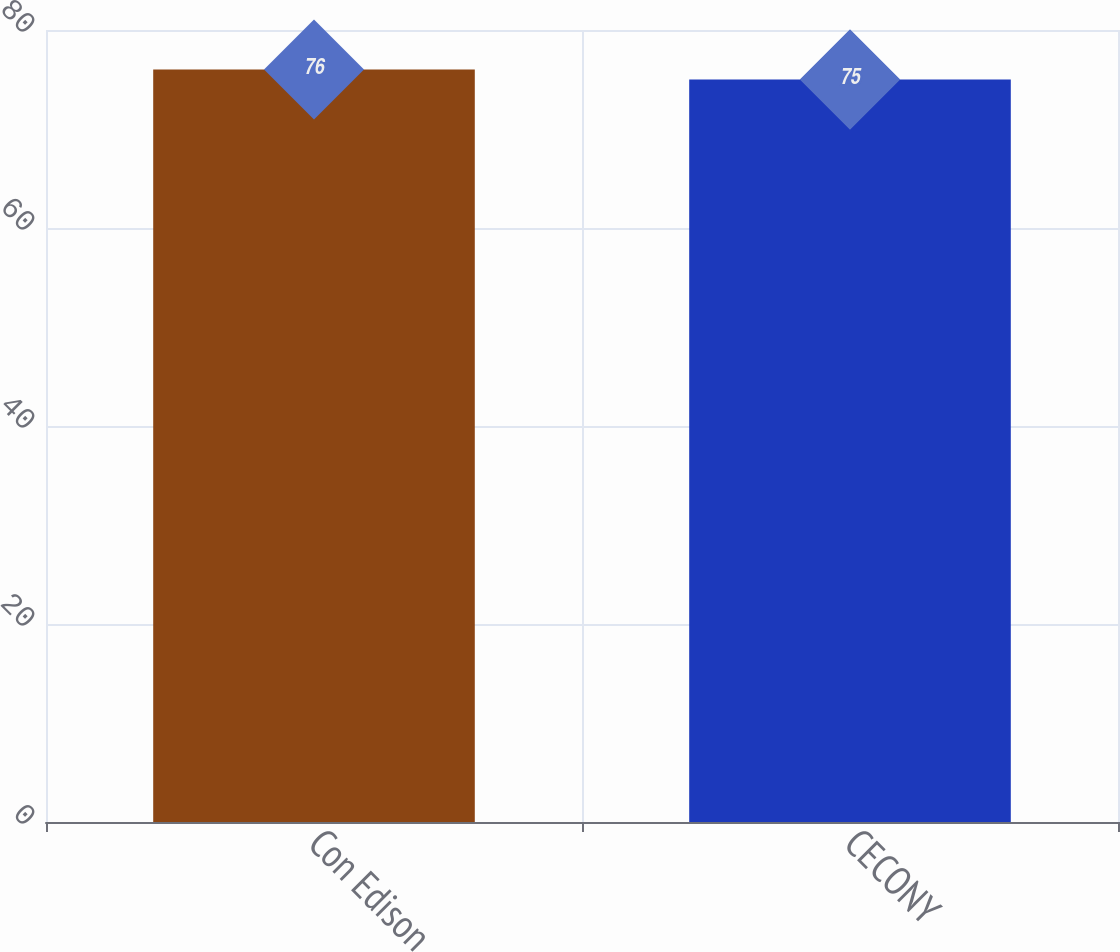Convert chart to OTSL. <chart><loc_0><loc_0><loc_500><loc_500><bar_chart><fcel>Con Edison<fcel>CECONY<nl><fcel>76<fcel>75<nl></chart> 